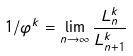Convert formula to latex. <formula><loc_0><loc_0><loc_500><loc_500>1 / \varphi ^ { k } = \lim _ { n \rightarrow \infty } \frac { L ^ { k } _ { n } } { L ^ { k } _ { n + 1 } }</formula> 